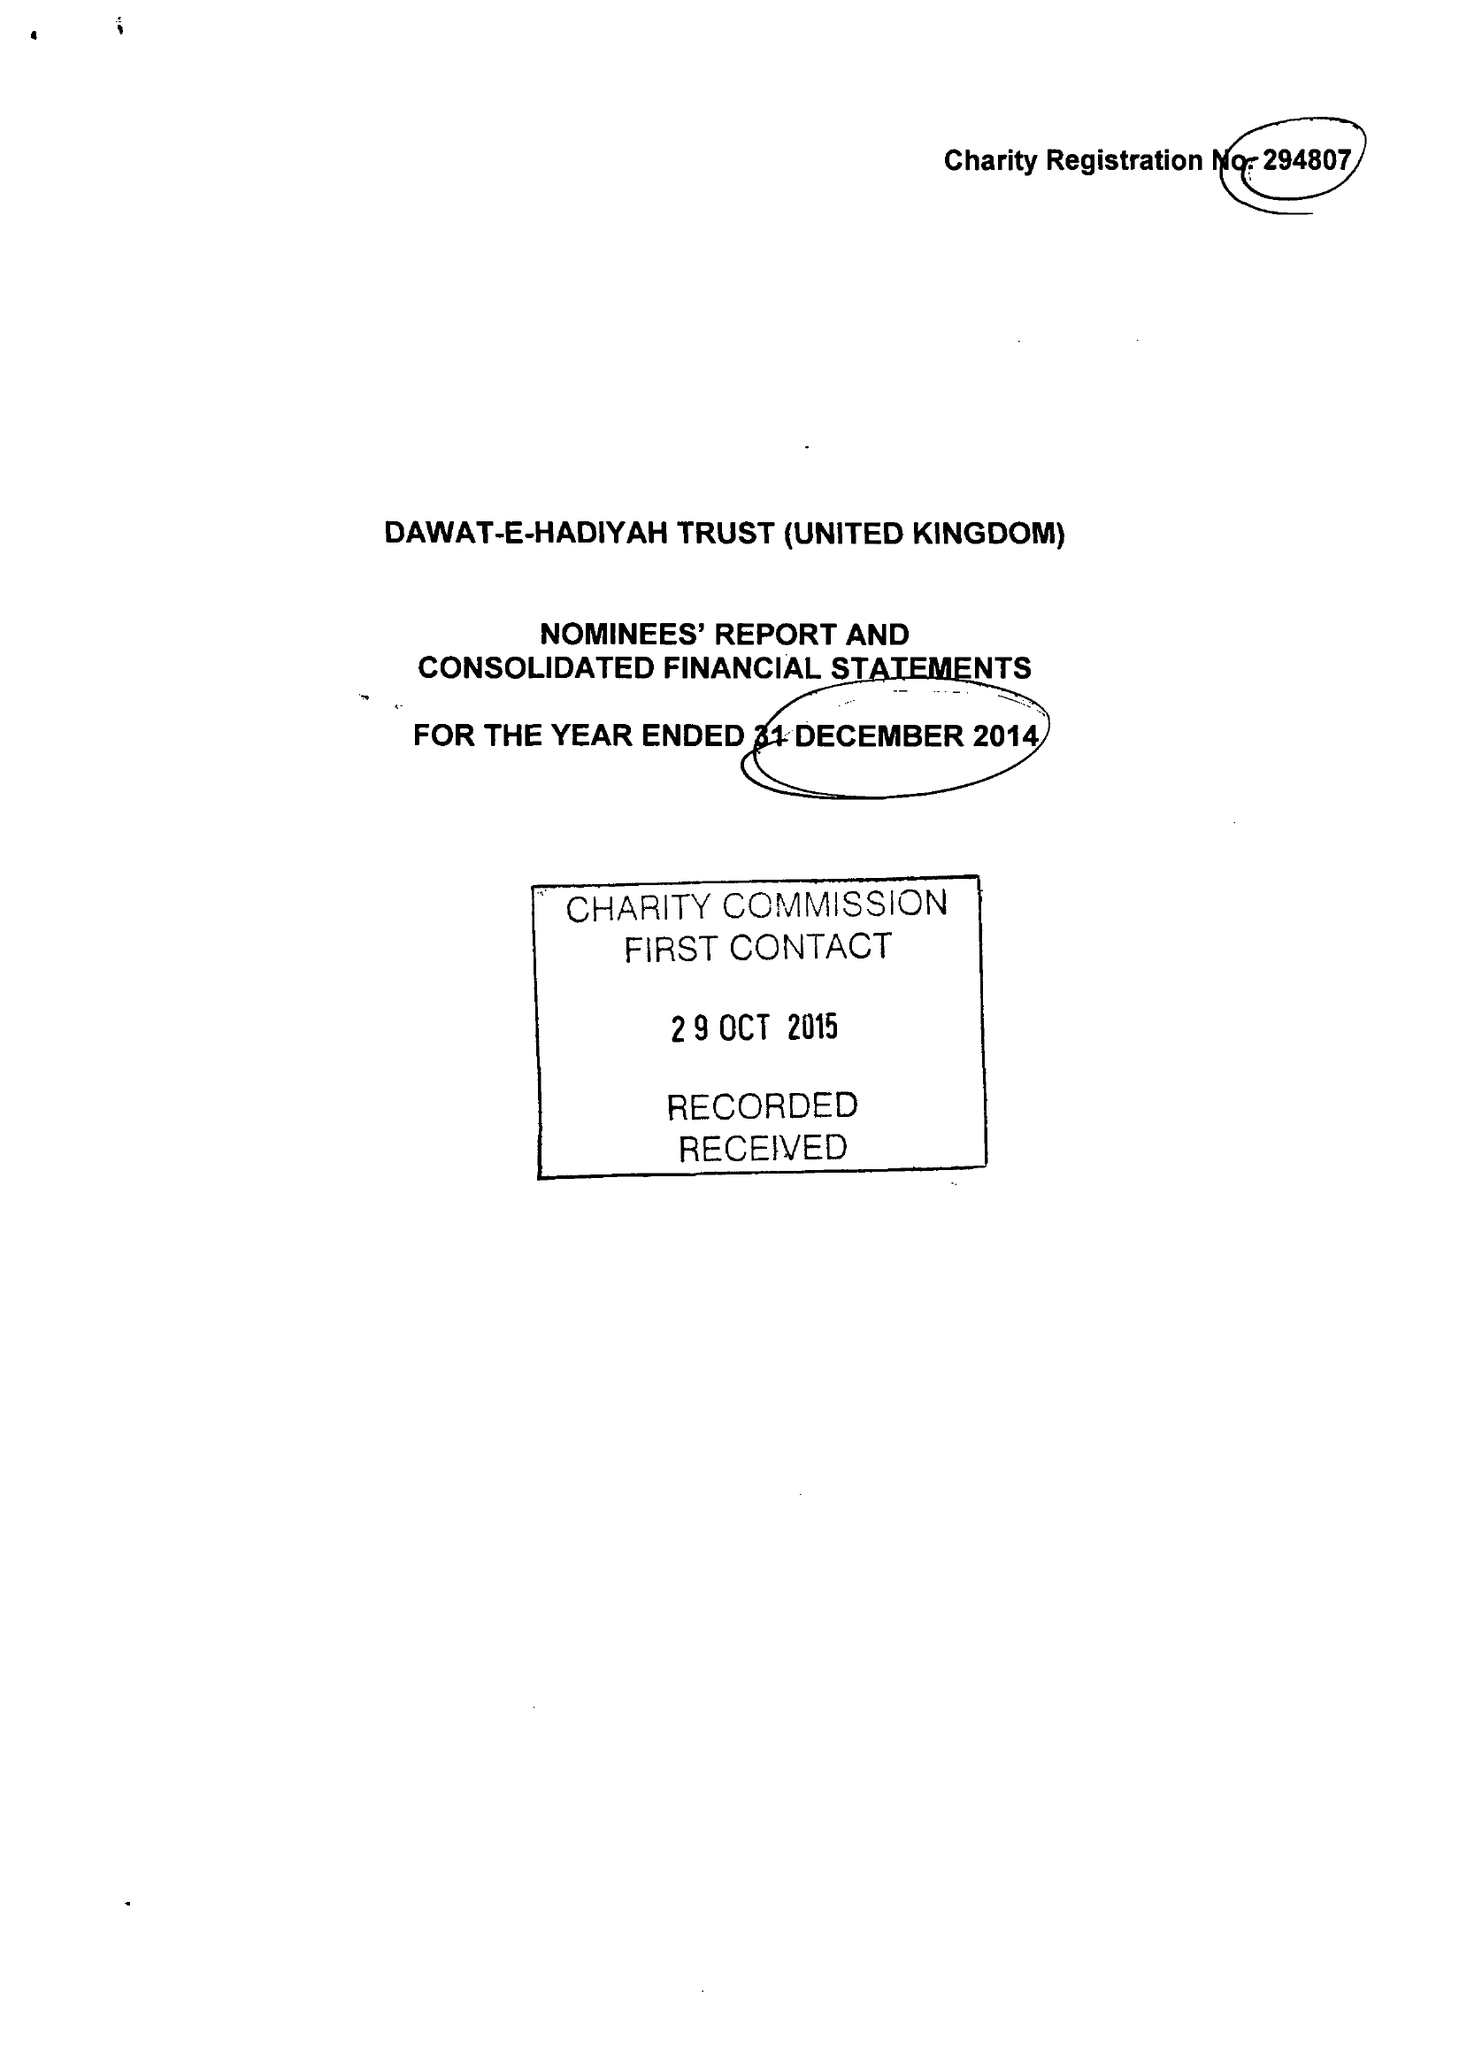What is the value for the charity_name?
Answer the question using a single word or phrase. Dawat-E-Hadiyah Trust (United Kingdom) 